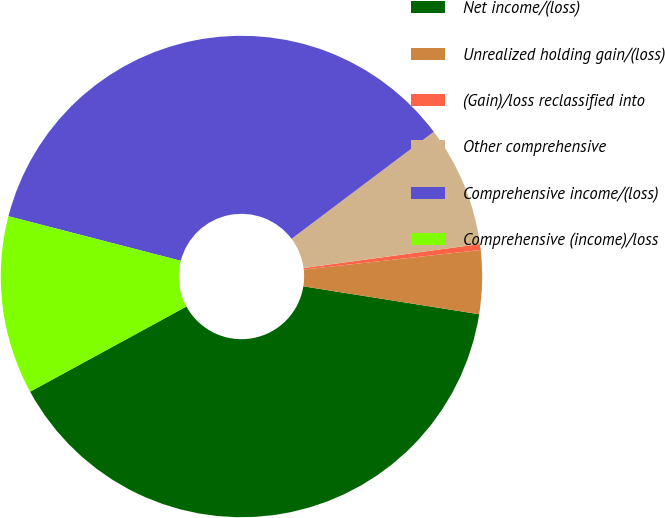<chart> <loc_0><loc_0><loc_500><loc_500><pie_chart><fcel>Net income/(loss)<fcel>Unrealized holding gain/(loss)<fcel>(Gain)/loss reclassified into<fcel>Other comprehensive<fcel>Comprehensive income/(loss)<fcel>Comprehensive (income)/loss<nl><fcel>39.55%<fcel>4.26%<fcel>0.4%<fcel>8.11%<fcel>35.7%<fcel>11.97%<nl></chart> 